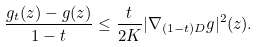<formula> <loc_0><loc_0><loc_500><loc_500>\frac { g _ { t } ( z ) - g ( z ) } { 1 - t } \leq \frac { t } { 2 K } | \nabla _ { ( 1 - t ) D } g | ^ { 2 } ( z ) .</formula> 